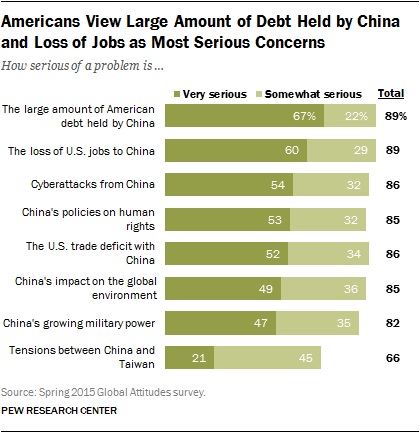Draw attention to some important aspects in this diagram. Ninety categories can be found in the chart. The average of the two smallest light green bars is 40. 